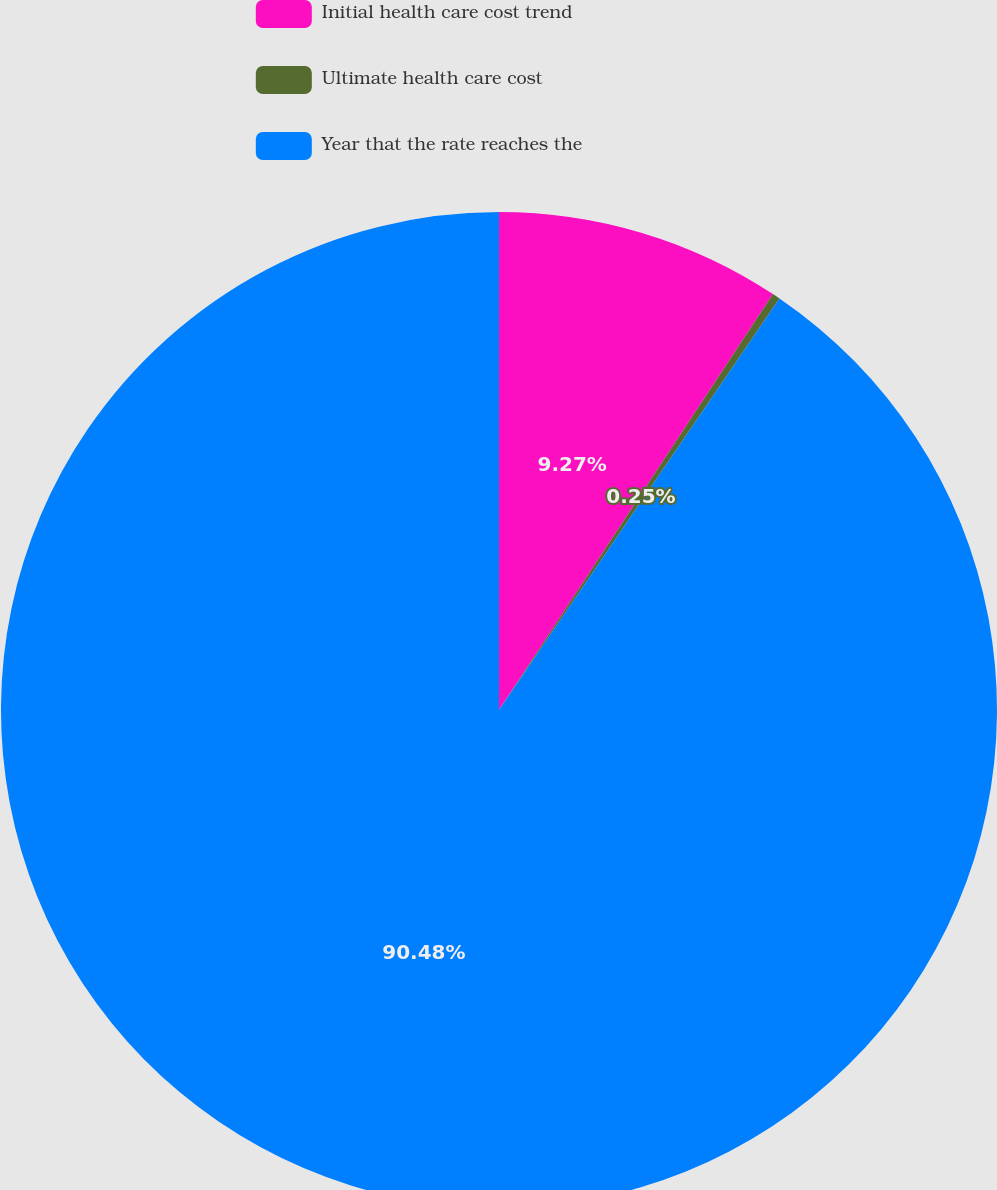Convert chart to OTSL. <chart><loc_0><loc_0><loc_500><loc_500><pie_chart><fcel>Initial health care cost trend<fcel>Ultimate health care cost<fcel>Year that the rate reaches the<nl><fcel>9.27%<fcel>0.25%<fcel>90.48%<nl></chart> 